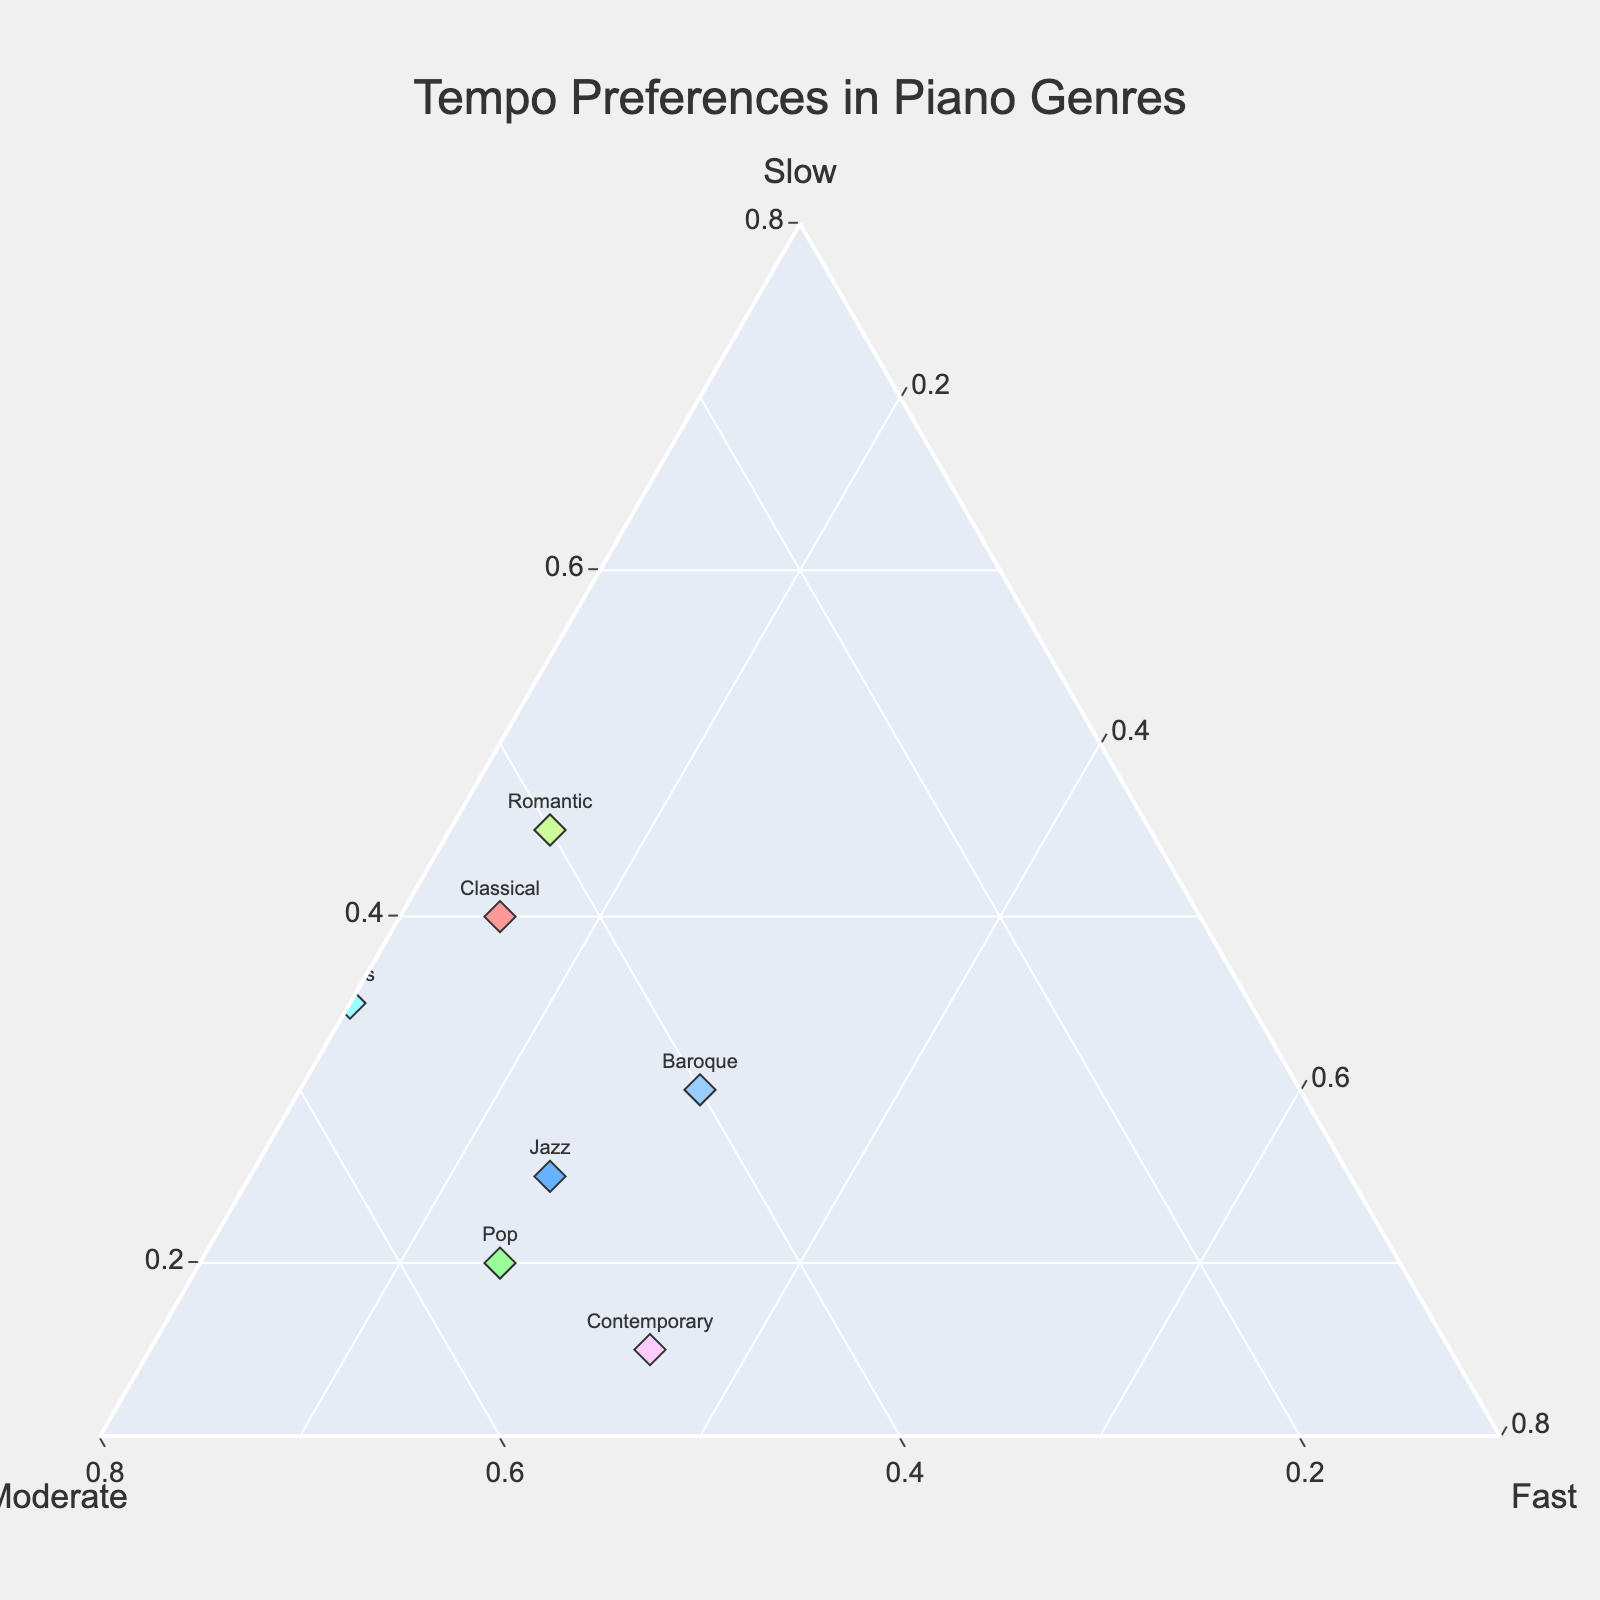What's the title of the ternary plot? The title of a ternary plot is typically featured at the top of the plot. By looking at the top of the figure, you can see the title which is "Tempo Preferences in Piano Genres".
Answer: Tempo Preferences in Piano Genres How many piano genres are represented in the plot? Each genre is marked with a text label accompanying the markers in the plot. By counting these distinct labels, we can determine the number of genres. Count the different text labels to conclude there are 10 genres.
Answer: 10 Which genre has the highest proportion of fast tempo? By focusing on the fast axis (depicted as one of the three sides of the ternary plot), identify the genre whose marker is closest to the fast corner. In this figure, Boogie-woogie is closest to the fast corner with a proportion of 0.65.
Answer: Boogie-woogie Which genre has the highest proportion of slow tempo and what is the proportion? To find the genre with the highest slow tempo, look for the marker closest to the slow axis corner. Ballads is the genre closest to the slow corner with a proportion of 0.70.
Answer: Ballads, 0.70 Compare the tempo preferences of Baroque and Romantic genres. Which has a higher proportion of moderate tempo? Locate the markers for Baroque and Romantic. Check their respective positions along the moderate axis. Baroque has a moderate tempo proportion of 0.40 while Romantic has a proportion of 0.40. Since both are equal, neither has a higher proportion.
Answer: Both are equal (0.40) Which genre has a similar tempo distribution to Pop? To find genres with a similar distribution, we look for markers positioned near the Pop genre marker. Checking the positions, Jazz appears to have similar ratios with moderate and fast tempos being relatively close to Pop's values.
Answer: Jazz Calculate the average proportion of moderate tempo for Classical, Jazz, and Pop genres. First, identify the moderate tempo values for Classical (0.45), Jazz (0.50), and Pop (0.55). Add these values: 0.45 + 0.50 + 0.55 = 1.50. Then, divide by the number of genres (3) to get the average: 1.50 / 3 = 0.50.
Answer: 0.50 Is there any genre with a higher proportion of slow tempo than moderate tempo? Check each genre's proportions. For example, Ballads has 0.70 slow and 0.25 moderate, and Romantic has 0.45 slow and 0.40 moderate, both of which have higher slow than moderate.
Answer: Yes Which genre shows the most balance between fast and slow tempos? Look for genres where the proportions of fast and slow are closest. Baroque has 0.30 fast and 0.30 slow, making it the most balanced in terms of these tempos.
Answer: Baroque Among Blues, Contemporary, and Boogie-woogie, which has the highest proportion of moderate tempo? Find the moderate proportions for Blues (0.55), Contemporary (0.50), and Boogie-woogie (0.30). Blues has the highest at 0.55.
Answer: Blues 